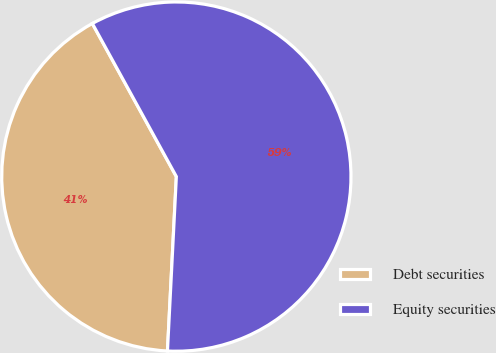Convert chart to OTSL. <chart><loc_0><loc_0><loc_500><loc_500><pie_chart><fcel>Debt securities<fcel>Equity securities<nl><fcel>41.2%<fcel>58.8%<nl></chart> 